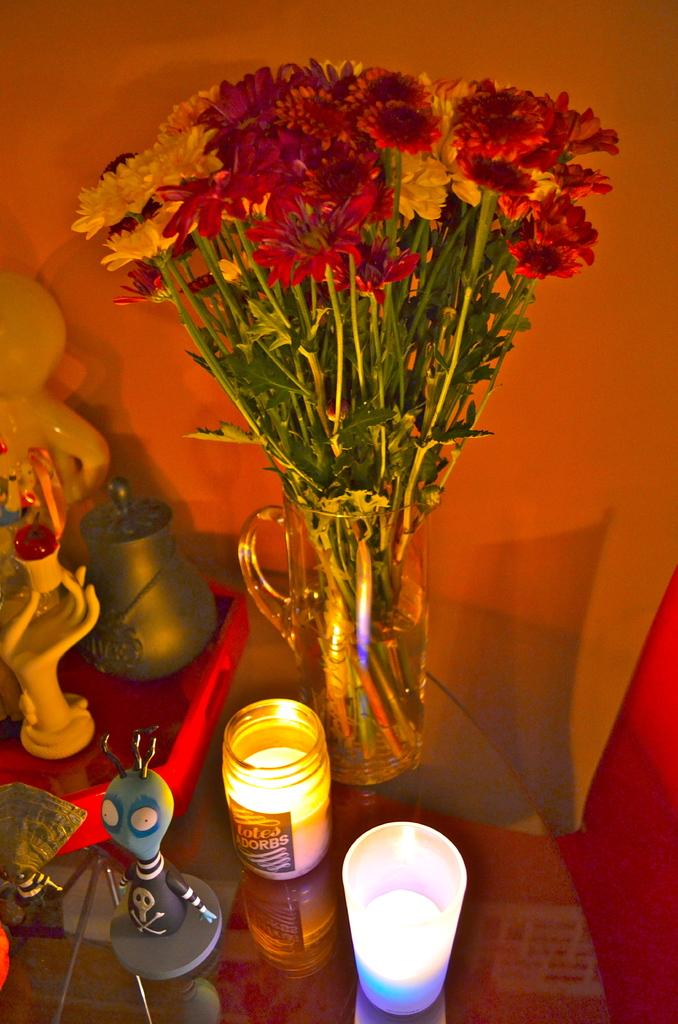What type of furniture is present in the image? There is a table in the image. What is placed on the table? There is a flower vase and toys on the table. Are there any fairies visible in the image? No, there are no fairies present in the image. What type of army is depicted in the image? There is no army or any military-related objects present in the image. 